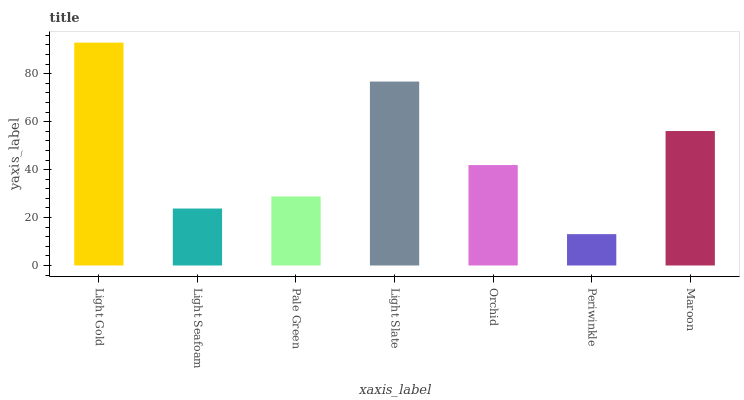Is Periwinkle the minimum?
Answer yes or no. Yes. Is Light Gold the maximum?
Answer yes or no. Yes. Is Light Seafoam the minimum?
Answer yes or no. No. Is Light Seafoam the maximum?
Answer yes or no. No. Is Light Gold greater than Light Seafoam?
Answer yes or no. Yes. Is Light Seafoam less than Light Gold?
Answer yes or no. Yes. Is Light Seafoam greater than Light Gold?
Answer yes or no. No. Is Light Gold less than Light Seafoam?
Answer yes or no. No. Is Orchid the high median?
Answer yes or no. Yes. Is Orchid the low median?
Answer yes or no. Yes. Is Light Seafoam the high median?
Answer yes or no. No. Is Light Gold the low median?
Answer yes or no. No. 